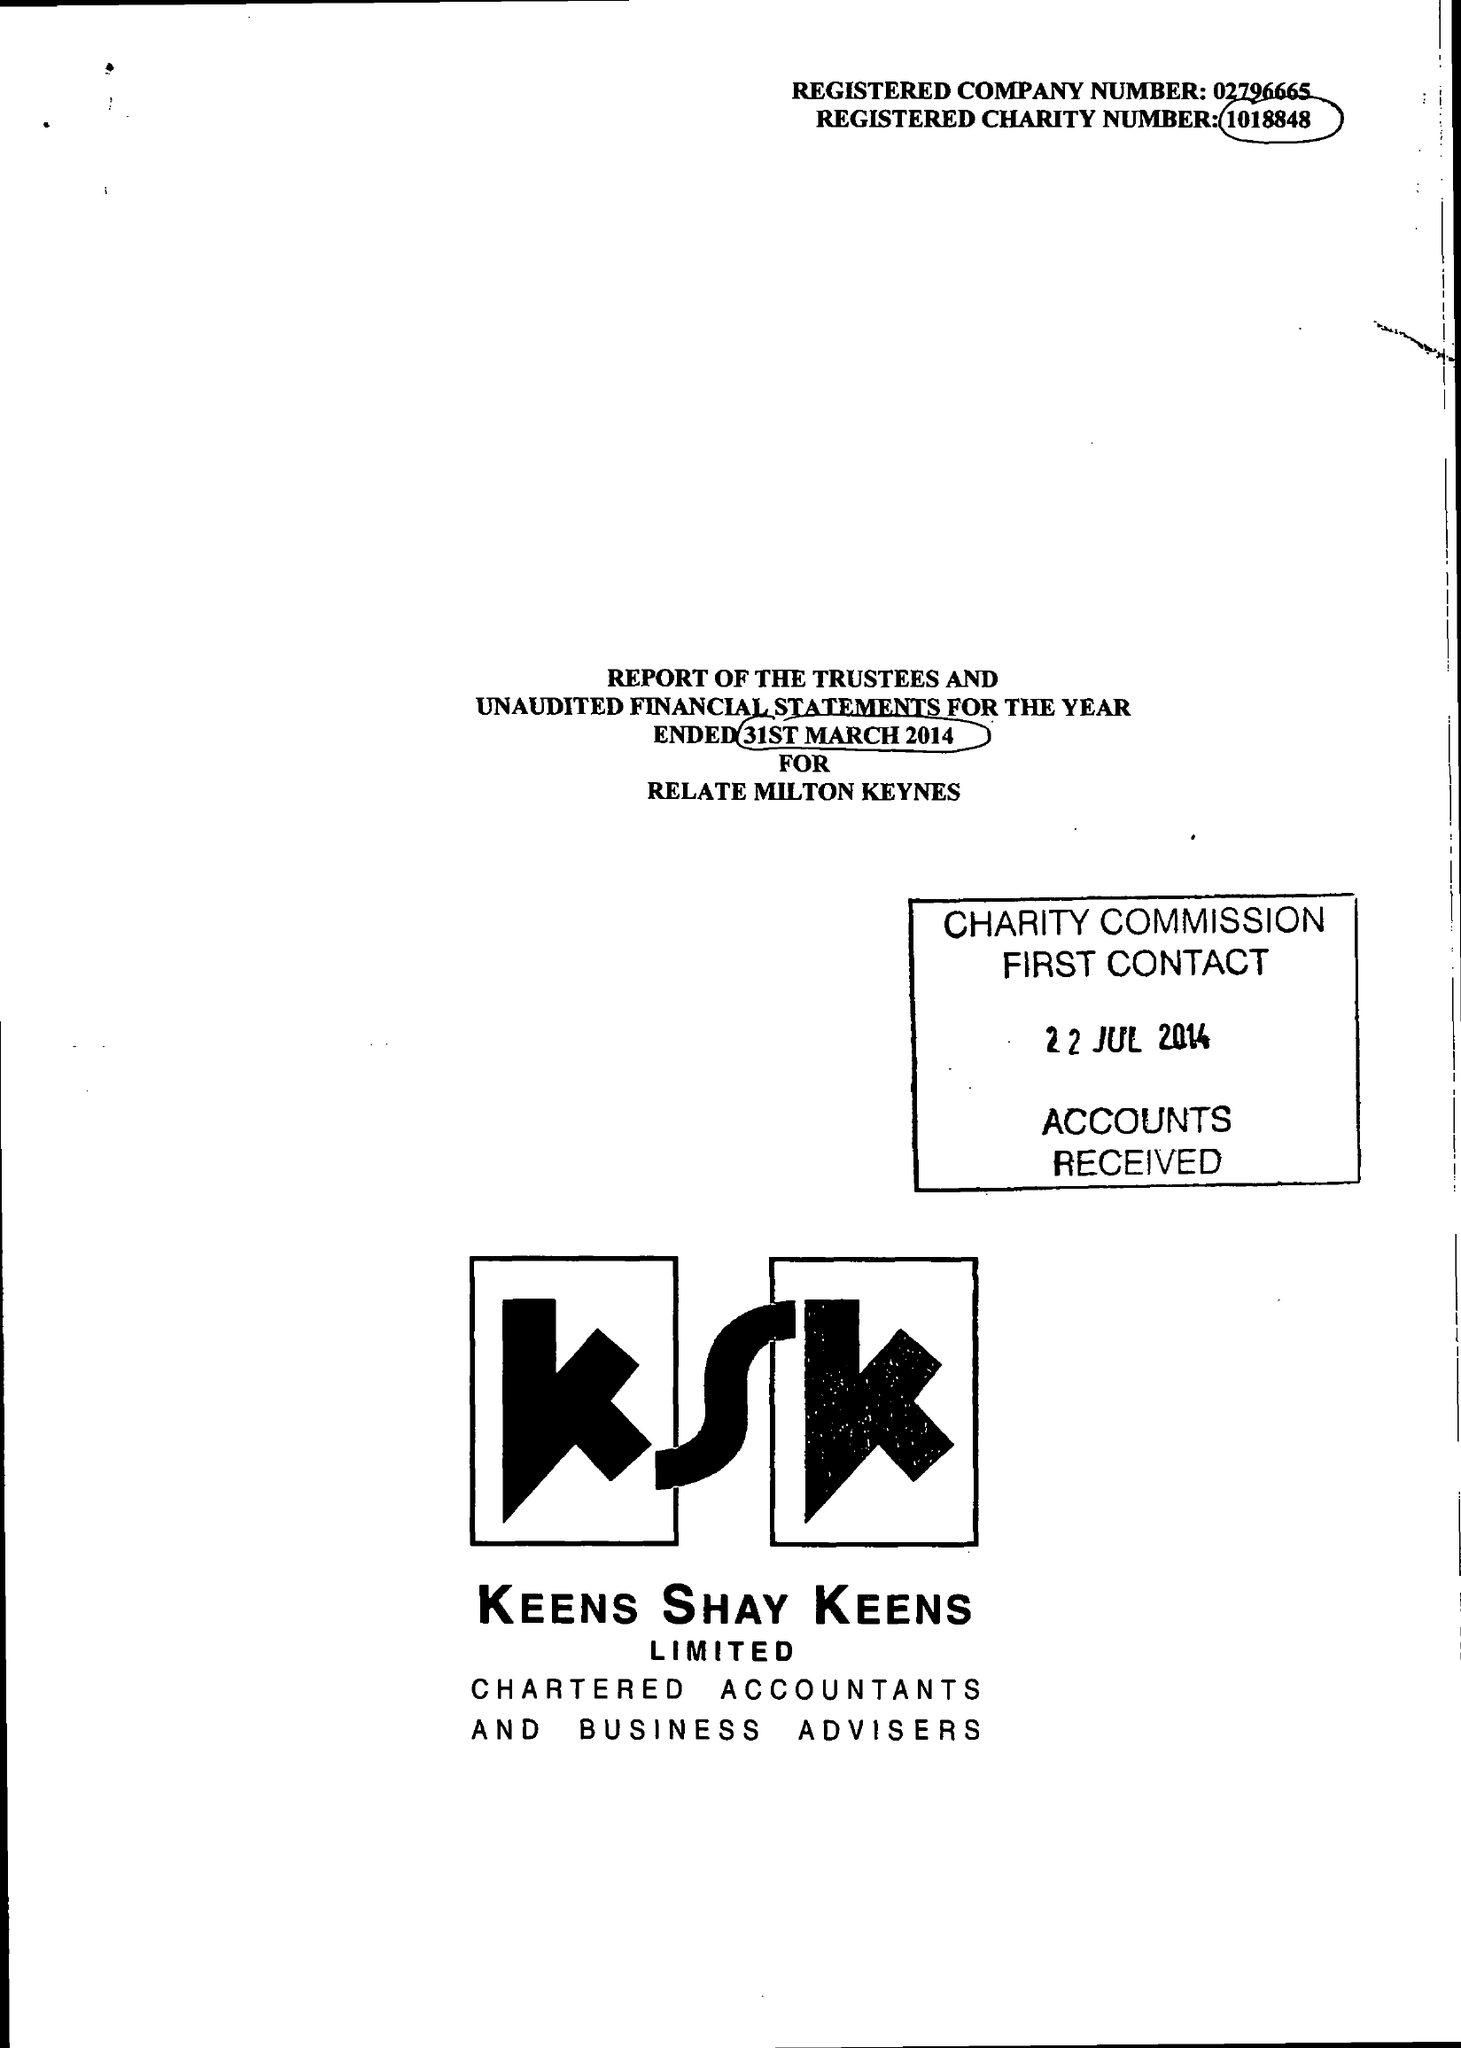What is the value for the income_annually_in_british_pounds?
Answer the question using a single word or phrase. 190401.00 